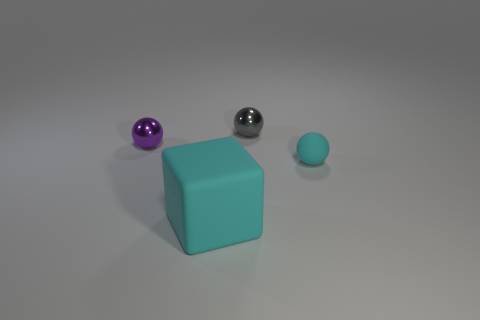Subtract 1 balls. How many balls are left? 2 Subtract all small metal balls. How many balls are left? 1 Add 3 gray things. How many objects exist? 7 Subtract all blocks. How many objects are left? 3 Add 2 large purple matte objects. How many large purple matte objects exist? 2 Subtract 1 cyan blocks. How many objects are left? 3 Subtract all red metallic cylinders. Subtract all metallic objects. How many objects are left? 2 Add 4 big objects. How many big objects are left? 5 